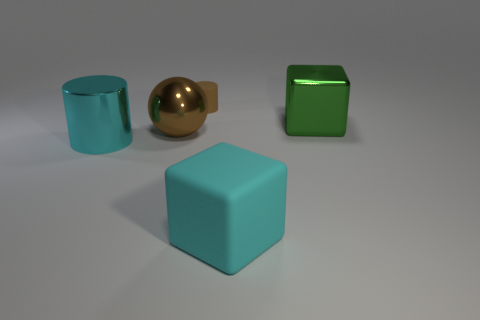Add 5 large green metal objects. How many objects exist? 10 Add 5 big matte cubes. How many big matte cubes exist? 6 Subtract 1 cyan blocks. How many objects are left? 4 Subtract all cubes. How many objects are left? 3 Subtract all large brown balls. Subtract all big cyan rubber cubes. How many objects are left? 3 Add 1 green metallic things. How many green metallic things are left? 2 